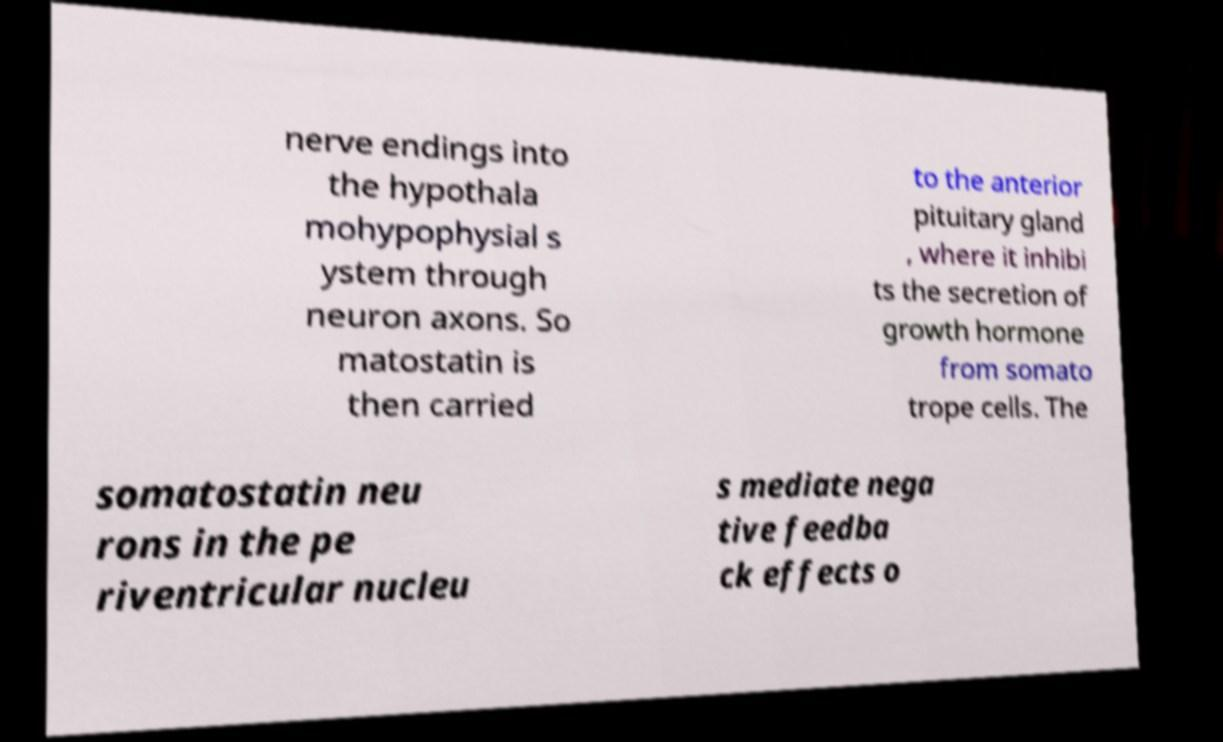Could you extract and type out the text from this image? nerve endings into the hypothala mohypophysial s ystem through neuron axons. So matostatin is then carried to the anterior pituitary gland , where it inhibi ts the secretion of growth hormone from somato trope cells. The somatostatin neu rons in the pe riventricular nucleu s mediate nega tive feedba ck effects o 